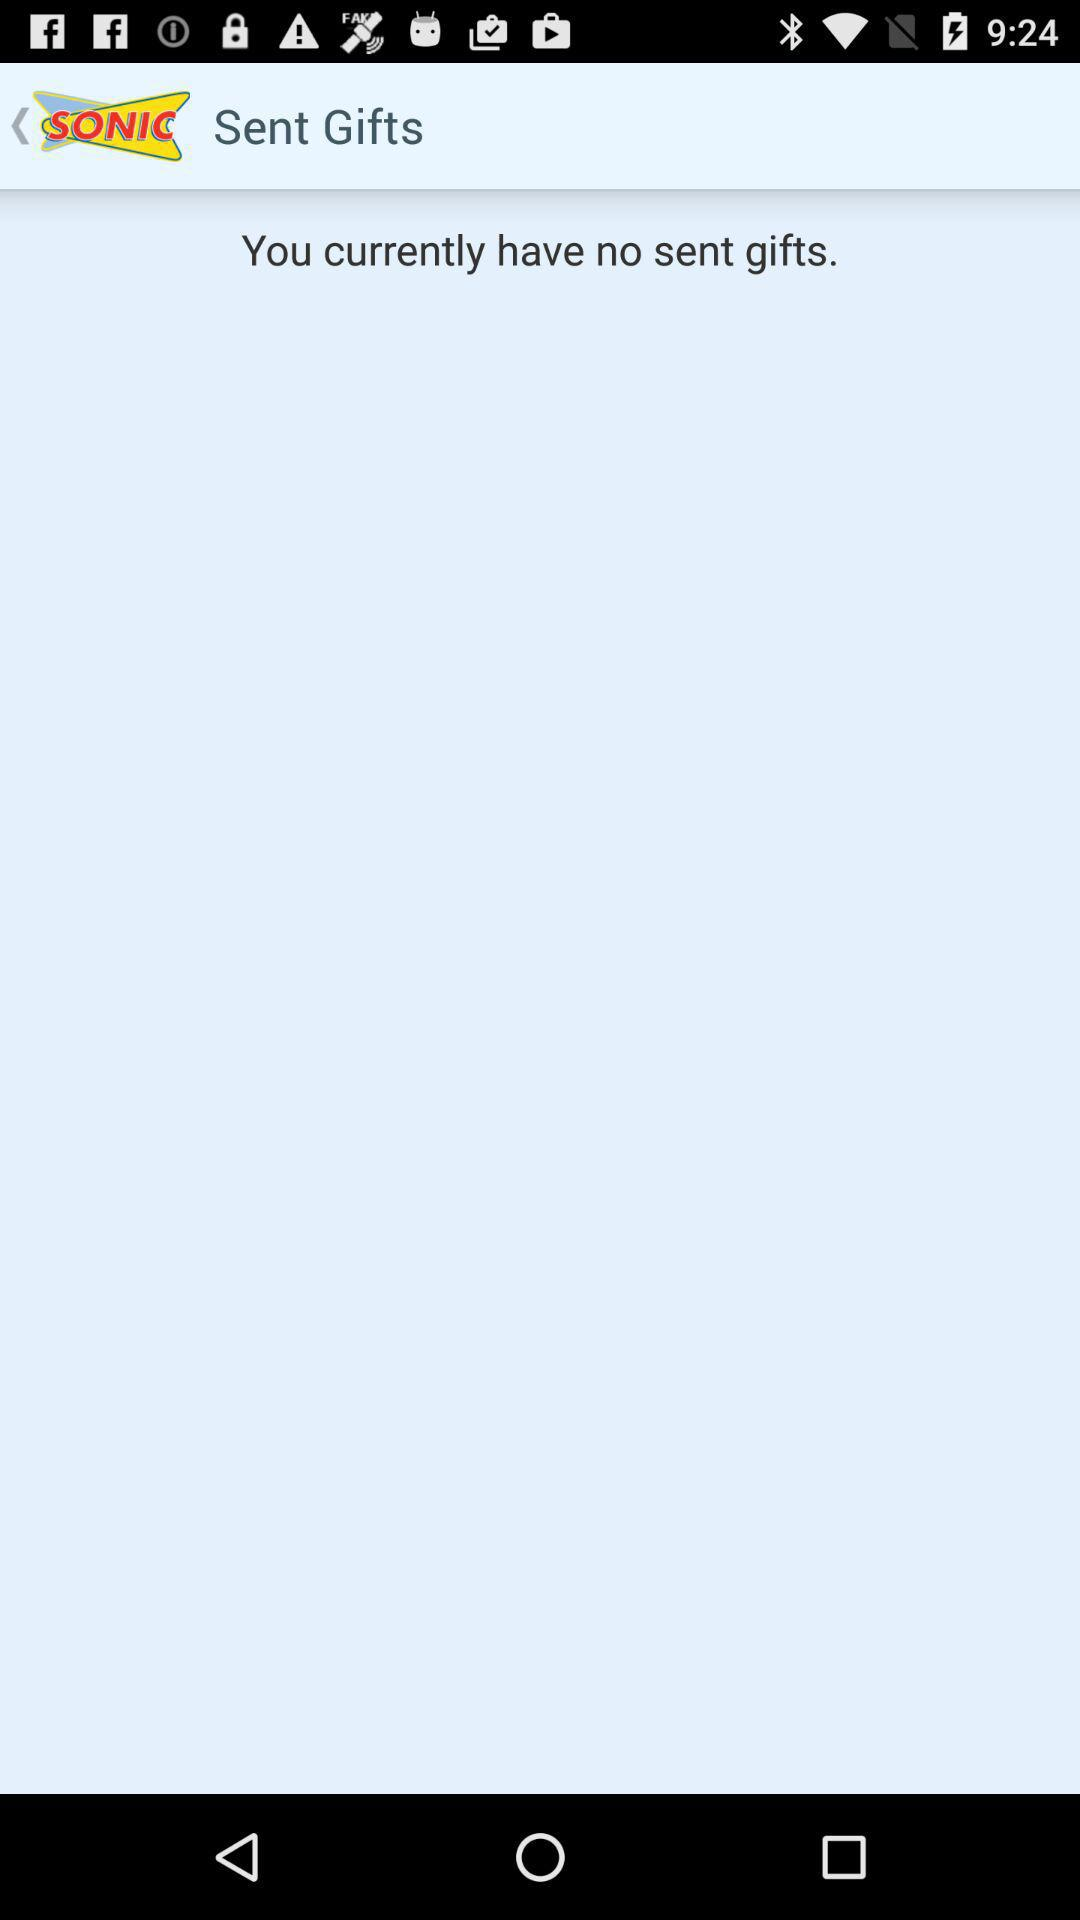How many gifts have been sent?
Answer the question using a single word or phrase. 0 